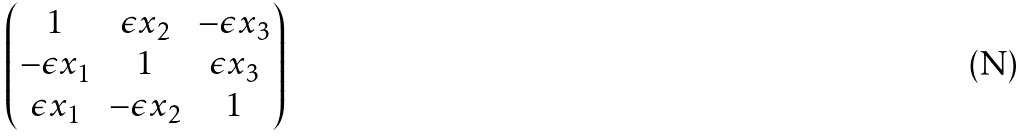<formula> <loc_0><loc_0><loc_500><loc_500>\begin{pmatrix} 1 & \epsilon x _ { 2 } & - \epsilon x _ { 3 } \\ - \epsilon x _ { 1 } & 1 & \epsilon x _ { 3 } \\ \epsilon x _ { 1 } & - \epsilon x _ { 2 } & 1 \end{pmatrix}</formula> 